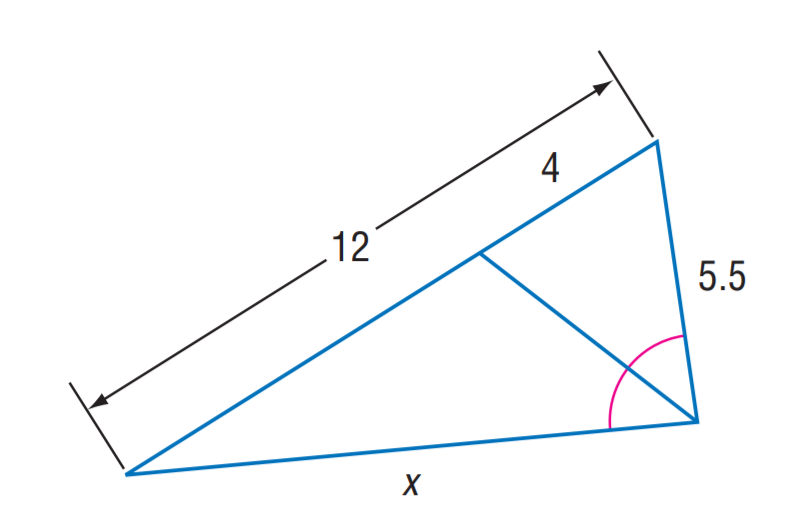Answer the mathemtical geometry problem and directly provide the correct option letter.
Question: Find x.
Choices: A: 5.5 B: 11 C: 16.5 D: 22 B 